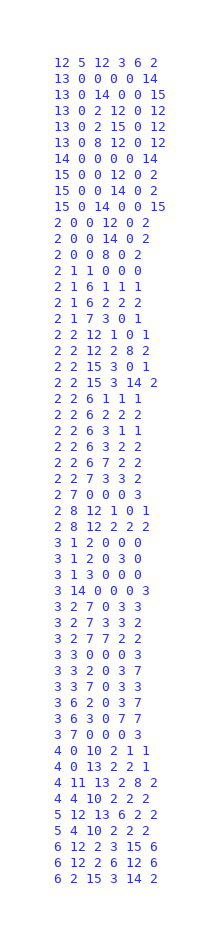<code> <loc_0><loc_0><loc_500><loc_500><_SQL_>12 5 12 3 6 2
13 0 0 0 0 14
13 0 14 0 0 15
13 0 2 12 0 12
13 0 2 15 0 12
13 0 8 12 0 12
14 0 0 0 0 14
15 0 0 12 0 2
15 0 0 14 0 2
15 0 14 0 0 15
2 0 0 12 0 2
2 0 0 14 0 2
2 0 0 8 0 2
2 1 1 0 0 0
2 1 6 1 1 1
2 1 6 2 2 2
2 1 7 3 0 1
2 2 12 1 0 1
2 2 12 2 8 2
2 2 15 3 0 1
2 2 15 3 14 2
2 2 6 1 1 1
2 2 6 2 2 2
2 2 6 3 1 1
2 2 6 3 2 2
2 2 6 7 2 2
2 2 7 3 3 2
2 7 0 0 0 3
2 8 12 1 0 1
2 8 12 2 2 2
3 1 2 0 0 0
3 1 2 0 3 0
3 1 3 0 0 0
3 14 0 0 0 3
3 2 7 0 3 3
3 2 7 3 3 2
3 2 7 7 2 2
3 3 0 0 0 3
3 3 2 0 3 7
3 3 7 0 3 3
3 6 2 0 3 7
3 6 3 0 7 7
3 7 0 0 0 3
4 0 10 2 1 1
4 0 13 2 2 1
4 11 13 2 8 2
4 4 10 2 2 2
5 12 13 6 2 2
5 4 10 2 2 2
6 12 2 3 15 6
6 12 2 6 12 6
6 2 15 3 14 2</code> 